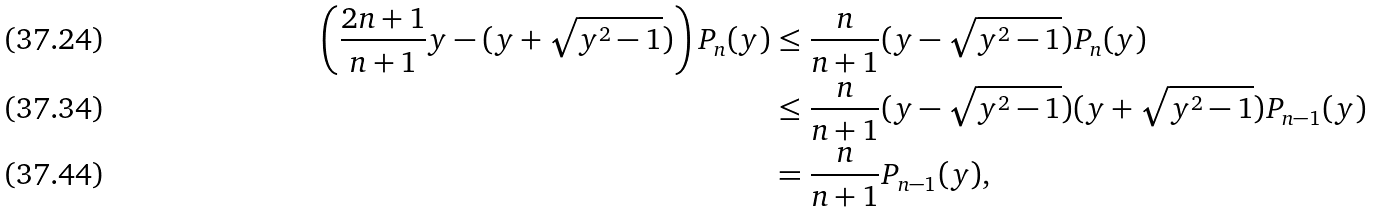<formula> <loc_0><loc_0><loc_500><loc_500>\left ( \frac { 2 n + 1 } { n + 1 } y - ( y + \sqrt { y ^ { 2 } - 1 } ) \right ) P _ { n } ( y ) & \leq \frac { n } { n + 1 } ( y - \sqrt { y ^ { 2 } - 1 } ) P _ { n } ( y ) \\ & \leq \frac { n } { n + 1 } ( y - \sqrt { y ^ { 2 } - 1 } ) ( y + \sqrt { y ^ { 2 } - 1 } ) P _ { n - 1 } ( y ) \\ & = \frac { n } { n + 1 } P _ { n - 1 } ( y ) ,</formula> 